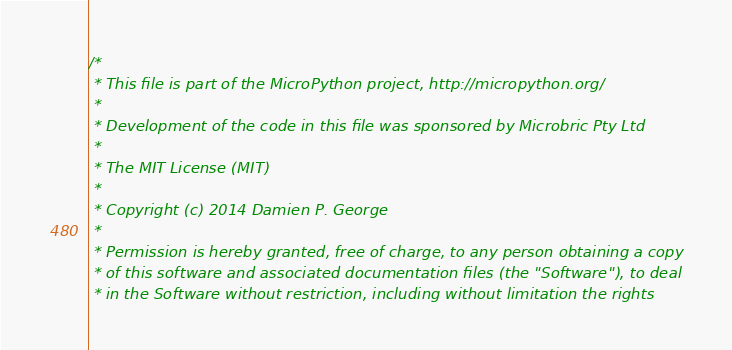Convert code to text. <code><loc_0><loc_0><loc_500><loc_500><_C_>/*
 * This file is part of the MicroPython project, http://micropython.org/
 *
 * Development of the code in this file was sponsored by Microbric Pty Ltd
 *
 * The MIT License (MIT)
 *
 * Copyright (c) 2014 Damien P. George
 *
 * Permission is hereby granted, free of charge, to any person obtaining a copy
 * of this software and associated documentation files (the "Software"), to deal
 * in the Software without restriction, including without limitation the rights</code> 